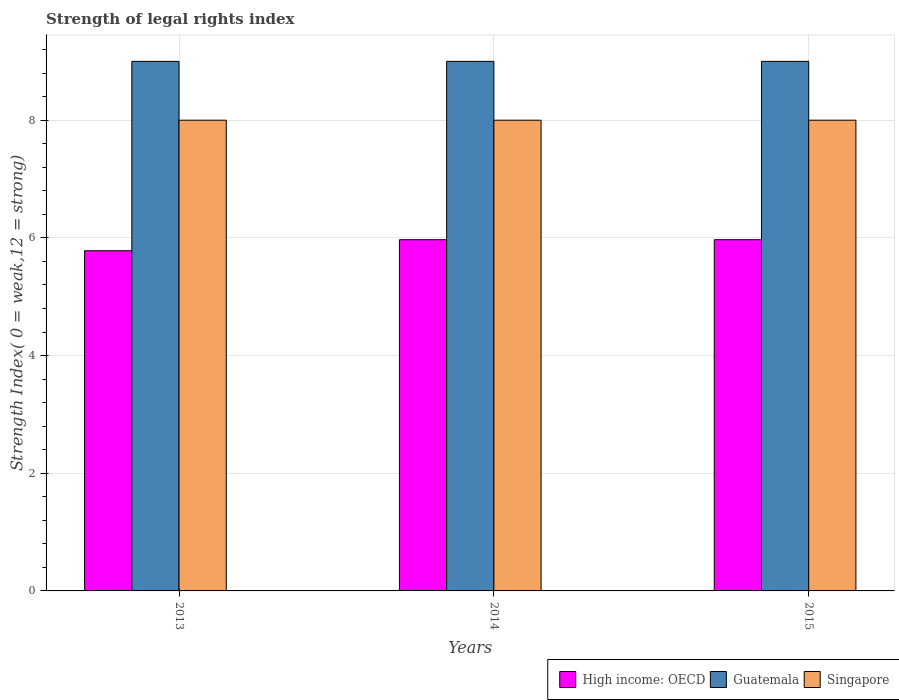How many different coloured bars are there?
Your answer should be very brief. 3. How many groups of bars are there?
Keep it short and to the point. 3. Are the number of bars per tick equal to the number of legend labels?
Offer a very short reply. Yes. Are the number of bars on each tick of the X-axis equal?
Your response must be concise. Yes. How many bars are there on the 1st tick from the right?
Keep it short and to the point. 3. What is the label of the 2nd group of bars from the left?
Keep it short and to the point. 2014. What is the strength index in High income: OECD in 2015?
Provide a short and direct response. 5.97. Across all years, what is the maximum strength index in Guatemala?
Offer a very short reply. 9. Across all years, what is the minimum strength index in Singapore?
Make the answer very short. 8. In which year was the strength index in High income: OECD minimum?
Offer a terse response. 2013. What is the total strength index in High income: OECD in the graph?
Offer a very short reply. 17.72. What is the difference between the strength index in High income: OECD in 2013 and that in 2014?
Keep it short and to the point. -0.19. What is the difference between the strength index in Singapore in 2015 and the strength index in High income: OECD in 2014?
Your answer should be very brief. 2.03. What is the average strength index in Guatemala per year?
Offer a very short reply. 9. In the year 2014, what is the difference between the strength index in Guatemala and strength index in High income: OECD?
Offer a terse response. 3.03. In how many years, is the strength index in Singapore greater than 0.4?
Provide a succinct answer. 3. Is the difference between the strength index in Guatemala in 2014 and 2015 greater than the difference between the strength index in High income: OECD in 2014 and 2015?
Provide a short and direct response. No. What is the difference between the highest and the lowest strength index in Guatemala?
Make the answer very short. 0. In how many years, is the strength index in Guatemala greater than the average strength index in Guatemala taken over all years?
Make the answer very short. 0. What does the 1st bar from the left in 2015 represents?
Your response must be concise. High income: OECD. What does the 2nd bar from the right in 2015 represents?
Your response must be concise. Guatemala. Is it the case that in every year, the sum of the strength index in Guatemala and strength index in High income: OECD is greater than the strength index in Singapore?
Make the answer very short. Yes. Are the values on the major ticks of Y-axis written in scientific E-notation?
Make the answer very short. No. Does the graph contain any zero values?
Provide a succinct answer. No. What is the title of the graph?
Provide a succinct answer. Strength of legal rights index. What is the label or title of the Y-axis?
Provide a short and direct response. Strength Index( 0 = weak,12 = strong). What is the Strength Index( 0 = weak,12 = strong) of High income: OECD in 2013?
Your answer should be compact. 5.78. What is the Strength Index( 0 = weak,12 = strong) in High income: OECD in 2014?
Offer a terse response. 5.97. What is the Strength Index( 0 = weak,12 = strong) in High income: OECD in 2015?
Offer a very short reply. 5.97. Across all years, what is the maximum Strength Index( 0 = weak,12 = strong) of High income: OECD?
Your answer should be very brief. 5.97. Across all years, what is the maximum Strength Index( 0 = weak,12 = strong) in Guatemala?
Offer a terse response. 9. Across all years, what is the minimum Strength Index( 0 = weak,12 = strong) in High income: OECD?
Your response must be concise. 5.78. Across all years, what is the minimum Strength Index( 0 = weak,12 = strong) of Singapore?
Your answer should be very brief. 8. What is the total Strength Index( 0 = weak,12 = strong) of High income: OECD in the graph?
Your response must be concise. 17.72. What is the difference between the Strength Index( 0 = weak,12 = strong) of High income: OECD in 2013 and that in 2014?
Your answer should be very brief. -0.19. What is the difference between the Strength Index( 0 = weak,12 = strong) in High income: OECD in 2013 and that in 2015?
Make the answer very short. -0.19. What is the difference between the Strength Index( 0 = weak,12 = strong) of Singapore in 2013 and that in 2015?
Ensure brevity in your answer.  0. What is the difference between the Strength Index( 0 = weak,12 = strong) of Guatemala in 2014 and that in 2015?
Your answer should be very brief. 0. What is the difference between the Strength Index( 0 = weak,12 = strong) of Singapore in 2014 and that in 2015?
Offer a terse response. 0. What is the difference between the Strength Index( 0 = weak,12 = strong) of High income: OECD in 2013 and the Strength Index( 0 = weak,12 = strong) of Guatemala in 2014?
Your answer should be compact. -3.22. What is the difference between the Strength Index( 0 = weak,12 = strong) in High income: OECD in 2013 and the Strength Index( 0 = weak,12 = strong) in Singapore in 2014?
Your response must be concise. -2.22. What is the difference between the Strength Index( 0 = weak,12 = strong) in Guatemala in 2013 and the Strength Index( 0 = weak,12 = strong) in Singapore in 2014?
Keep it short and to the point. 1. What is the difference between the Strength Index( 0 = weak,12 = strong) of High income: OECD in 2013 and the Strength Index( 0 = weak,12 = strong) of Guatemala in 2015?
Give a very brief answer. -3.22. What is the difference between the Strength Index( 0 = weak,12 = strong) of High income: OECD in 2013 and the Strength Index( 0 = weak,12 = strong) of Singapore in 2015?
Your response must be concise. -2.22. What is the difference between the Strength Index( 0 = weak,12 = strong) in Guatemala in 2013 and the Strength Index( 0 = weak,12 = strong) in Singapore in 2015?
Offer a very short reply. 1. What is the difference between the Strength Index( 0 = weak,12 = strong) of High income: OECD in 2014 and the Strength Index( 0 = weak,12 = strong) of Guatemala in 2015?
Your answer should be very brief. -3.03. What is the difference between the Strength Index( 0 = weak,12 = strong) of High income: OECD in 2014 and the Strength Index( 0 = weak,12 = strong) of Singapore in 2015?
Your answer should be very brief. -2.03. What is the difference between the Strength Index( 0 = weak,12 = strong) of Guatemala in 2014 and the Strength Index( 0 = weak,12 = strong) of Singapore in 2015?
Make the answer very short. 1. What is the average Strength Index( 0 = weak,12 = strong) of High income: OECD per year?
Provide a short and direct response. 5.91. What is the average Strength Index( 0 = weak,12 = strong) of Singapore per year?
Provide a short and direct response. 8. In the year 2013, what is the difference between the Strength Index( 0 = weak,12 = strong) of High income: OECD and Strength Index( 0 = weak,12 = strong) of Guatemala?
Keep it short and to the point. -3.22. In the year 2013, what is the difference between the Strength Index( 0 = weak,12 = strong) in High income: OECD and Strength Index( 0 = weak,12 = strong) in Singapore?
Keep it short and to the point. -2.22. In the year 2014, what is the difference between the Strength Index( 0 = weak,12 = strong) in High income: OECD and Strength Index( 0 = weak,12 = strong) in Guatemala?
Provide a short and direct response. -3.03. In the year 2014, what is the difference between the Strength Index( 0 = weak,12 = strong) of High income: OECD and Strength Index( 0 = weak,12 = strong) of Singapore?
Your response must be concise. -2.03. In the year 2014, what is the difference between the Strength Index( 0 = weak,12 = strong) in Guatemala and Strength Index( 0 = weak,12 = strong) in Singapore?
Your answer should be very brief. 1. In the year 2015, what is the difference between the Strength Index( 0 = weak,12 = strong) in High income: OECD and Strength Index( 0 = weak,12 = strong) in Guatemala?
Your answer should be compact. -3.03. In the year 2015, what is the difference between the Strength Index( 0 = weak,12 = strong) in High income: OECD and Strength Index( 0 = weak,12 = strong) in Singapore?
Make the answer very short. -2.03. In the year 2015, what is the difference between the Strength Index( 0 = weak,12 = strong) in Guatemala and Strength Index( 0 = weak,12 = strong) in Singapore?
Provide a succinct answer. 1. What is the ratio of the Strength Index( 0 = weak,12 = strong) in High income: OECD in 2013 to that in 2014?
Provide a succinct answer. 0.97. What is the ratio of the Strength Index( 0 = weak,12 = strong) in Singapore in 2013 to that in 2014?
Your response must be concise. 1. What is the ratio of the Strength Index( 0 = weak,12 = strong) in High income: OECD in 2013 to that in 2015?
Offer a terse response. 0.97. What is the ratio of the Strength Index( 0 = weak,12 = strong) of Guatemala in 2013 to that in 2015?
Ensure brevity in your answer.  1. What is the ratio of the Strength Index( 0 = weak,12 = strong) in Singapore in 2013 to that in 2015?
Offer a very short reply. 1. What is the ratio of the Strength Index( 0 = weak,12 = strong) of High income: OECD in 2014 to that in 2015?
Provide a short and direct response. 1. What is the ratio of the Strength Index( 0 = weak,12 = strong) in Guatemala in 2014 to that in 2015?
Your answer should be very brief. 1. What is the ratio of the Strength Index( 0 = weak,12 = strong) of Singapore in 2014 to that in 2015?
Keep it short and to the point. 1. What is the difference between the highest and the lowest Strength Index( 0 = weak,12 = strong) in High income: OECD?
Provide a succinct answer. 0.19. 